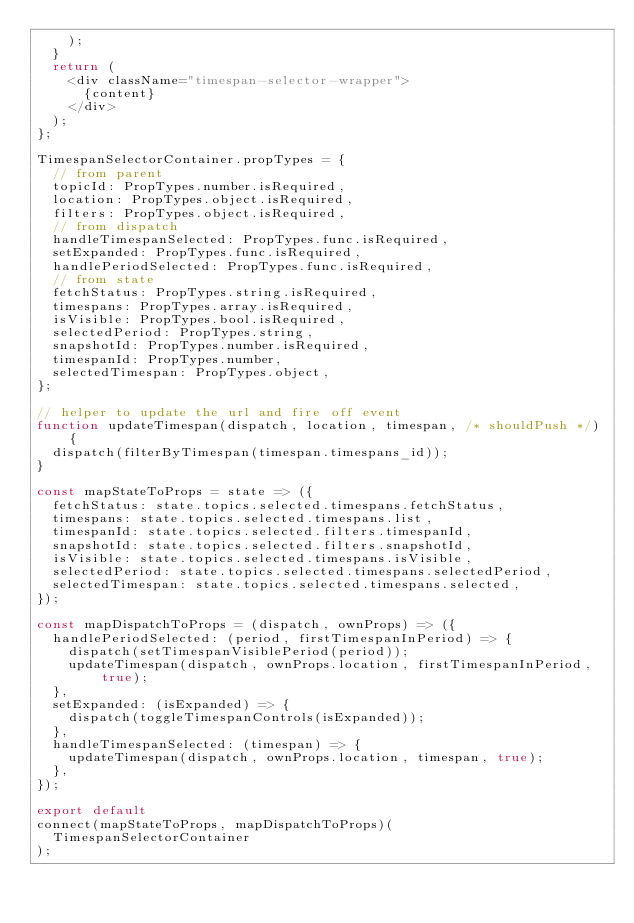<code> <loc_0><loc_0><loc_500><loc_500><_JavaScript_>    );
  }
  return (
    <div className="timespan-selector-wrapper">
      {content}
    </div>
  );
};

TimespanSelectorContainer.propTypes = {
  // from parent
  topicId: PropTypes.number.isRequired,
  location: PropTypes.object.isRequired,
  filters: PropTypes.object.isRequired,
  // from dispatch
  handleTimespanSelected: PropTypes.func.isRequired,
  setExpanded: PropTypes.func.isRequired,
  handlePeriodSelected: PropTypes.func.isRequired,
  // from state
  fetchStatus: PropTypes.string.isRequired,
  timespans: PropTypes.array.isRequired,
  isVisible: PropTypes.bool.isRequired,
  selectedPeriod: PropTypes.string,
  snapshotId: PropTypes.number.isRequired,
  timespanId: PropTypes.number,
  selectedTimespan: PropTypes.object,
};

// helper to update the url and fire off event
function updateTimespan(dispatch, location, timespan, /* shouldPush */) {
  dispatch(filterByTimespan(timespan.timespans_id));
}

const mapStateToProps = state => ({
  fetchStatus: state.topics.selected.timespans.fetchStatus,
  timespans: state.topics.selected.timespans.list,
  timespanId: state.topics.selected.filters.timespanId,
  snapshotId: state.topics.selected.filters.snapshotId,
  isVisible: state.topics.selected.timespans.isVisible,
  selectedPeriod: state.topics.selected.timespans.selectedPeriod,
  selectedTimespan: state.topics.selected.timespans.selected,
});

const mapDispatchToProps = (dispatch, ownProps) => ({
  handlePeriodSelected: (period, firstTimespanInPeriod) => {
    dispatch(setTimespanVisiblePeriod(period));
    updateTimespan(dispatch, ownProps.location, firstTimespanInPeriod, true);
  },
  setExpanded: (isExpanded) => {
    dispatch(toggleTimespanControls(isExpanded));
  },
  handleTimespanSelected: (timespan) => {
    updateTimespan(dispatch, ownProps.location, timespan, true);
  },
});

export default
connect(mapStateToProps, mapDispatchToProps)(
  TimespanSelectorContainer
);
</code> 